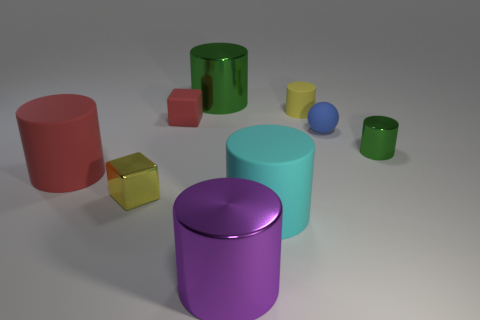Is the yellow matte cylinder the same size as the red matte cylinder?
Give a very brief answer. No. How many objects are either small shiny balls or yellow metallic blocks?
Provide a short and direct response. 1. What is the size of the metal cylinder that is left of the yellow cylinder and in front of the small red matte cube?
Ensure brevity in your answer.  Large. Is the number of small red blocks behind the small green shiny thing less than the number of big red rubber cylinders?
Give a very brief answer. No. There is a small blue object that is the same material as the large cyan cylinder; what shape is it?
Your answer should be very brief. Sphere. There is a metal thing that is right of the big cyan object; is it the same shape as the large metal object that is behind the small yellow rubber cylinder?
Offer a terse response. Yes. Is the number of metal things that are to the left of the tiny blue sphere less than the number of red rubber objects that are in front of the metallic cube?
Ensure brevity in your answer.  No. There is a large rubber object that is the same color as the tiny rubber block; what is its shape?
Your response must be concise. Cylinder. How many other rubber cubes are the same size as the yellow cube?
Provide a short and direct response. 1. Does the cylinder that is behind the tiny yellow cylinder have the same material as the tiny blue thing?
Your answer should be compact. No. 